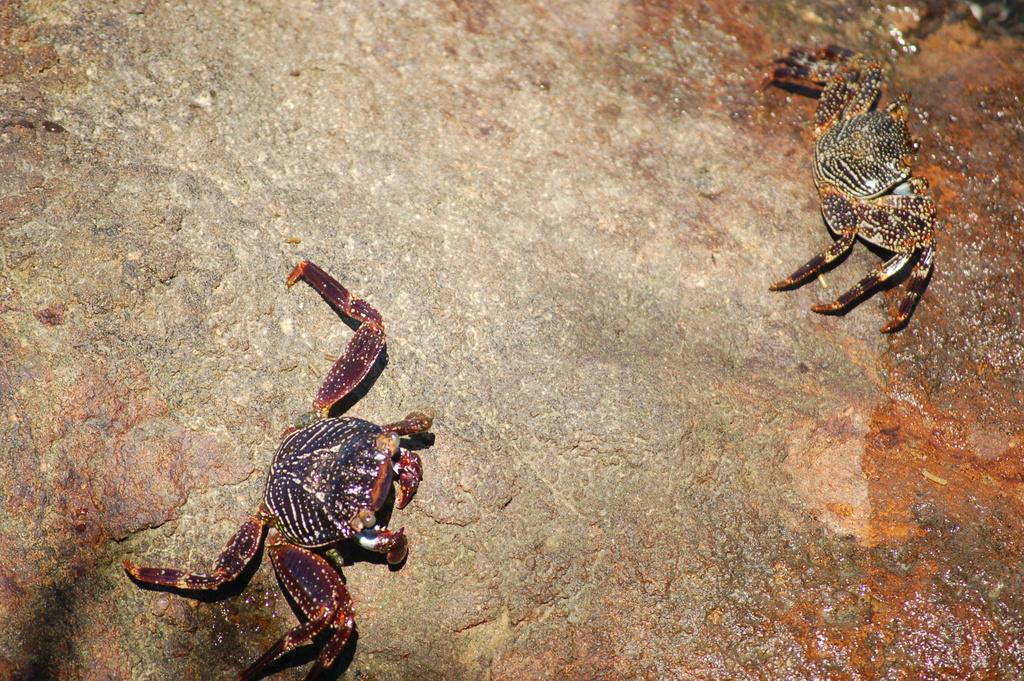Could you give a brief overview of what you see in this image? In this image we can see crabs on the ground. 